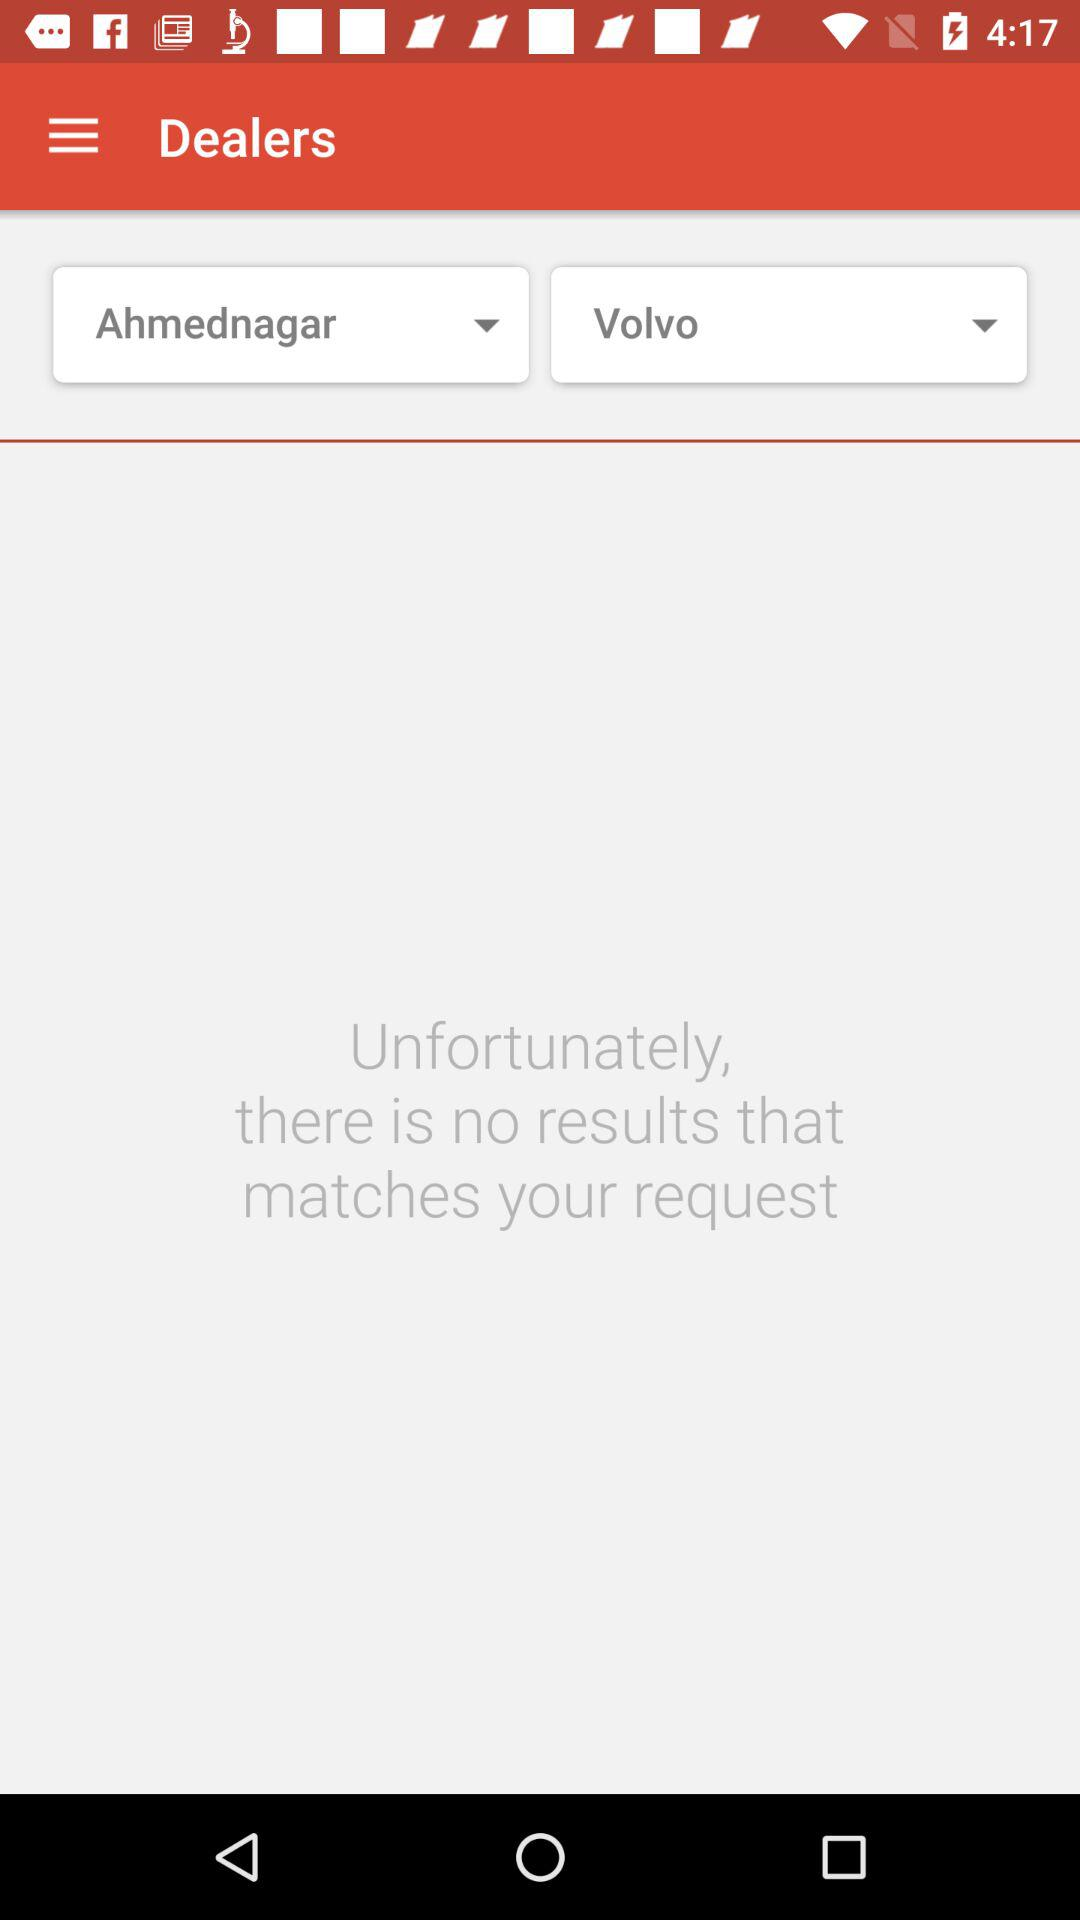What is the selected car manufacturer? The selected car manufacturer is "Volvo". 